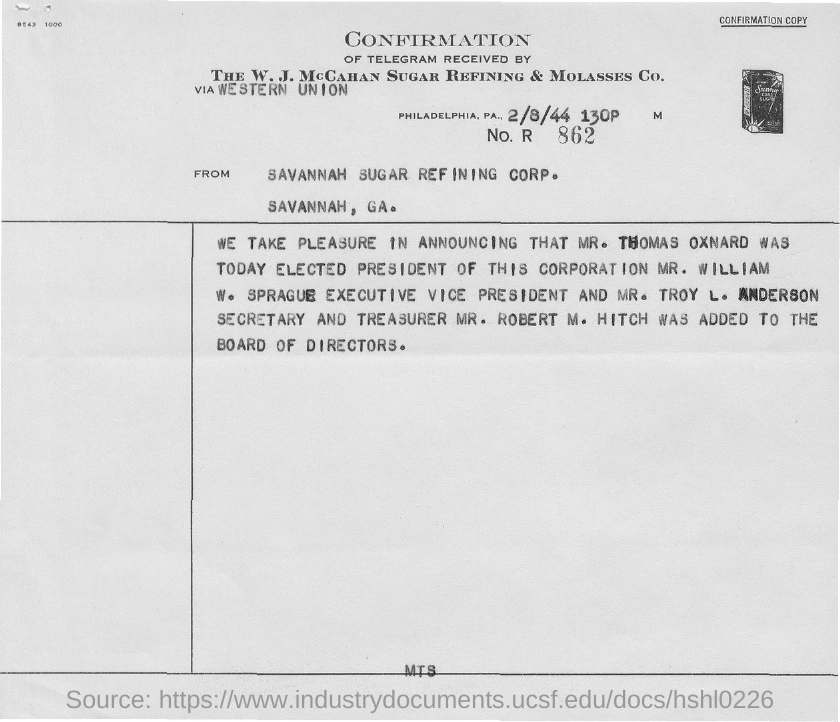Mention a couple of crucial points in this snapshot. The secretary's name is Mr. Troy L. Anderson. The date on the document is February 8, 1944. Mr. William W. Sprague was elected the Executive Vice President. The individual who serves as the Treasurer is named Mr. Robert M. Hitch. The President of the Corporation was elected as Mr. Thomas Oxnard. 